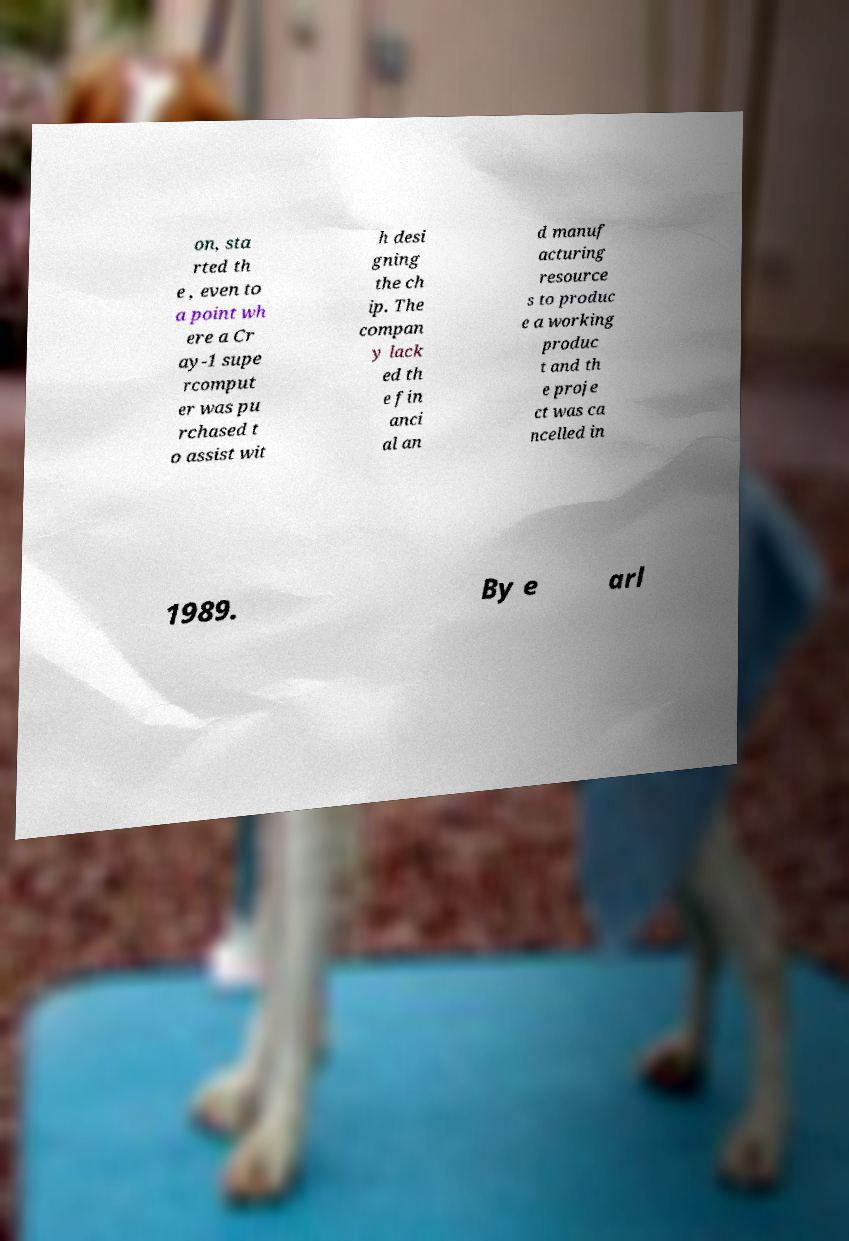Could you assist in decoding the text presented in this image and type it out clearly? on, sta rted th e , even to a point wh ere a Cr ay-1 supe rcomput er was pu rchased t o assist wit h desi gning the ch ip. The compan y lack ed th e fin anci al an d manuf acturing resource s to produc e a working produc t and th e proje ct was ca ncelled in 1989. By e arl 